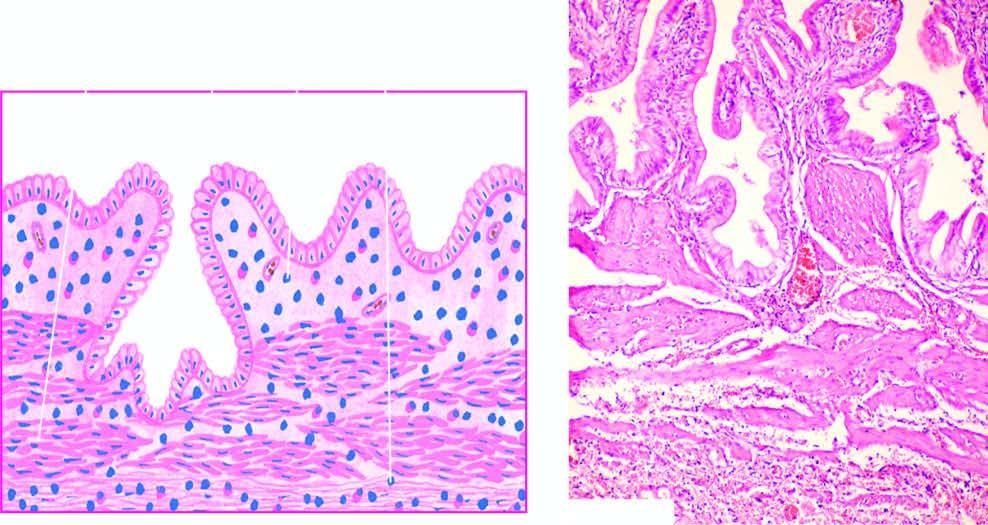s the lesion penetration of epithelium-lined spaces into the gallbladder wall in an area?
Answer the question using a single word or phrase. No 